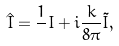<formula> <loc_0><loc_0><loc_500><loc_500>\hat { I } = { \frac { 1 } { } } I + i { \frac { k } { 8 \pi } } \tilde { I } ,</formula> 